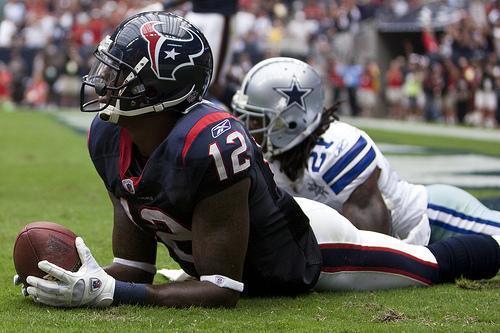How many people are shown in the photo?
Give a very brief answer. 2. How many footballs can be seen?
Give a very brief answer. 1. 